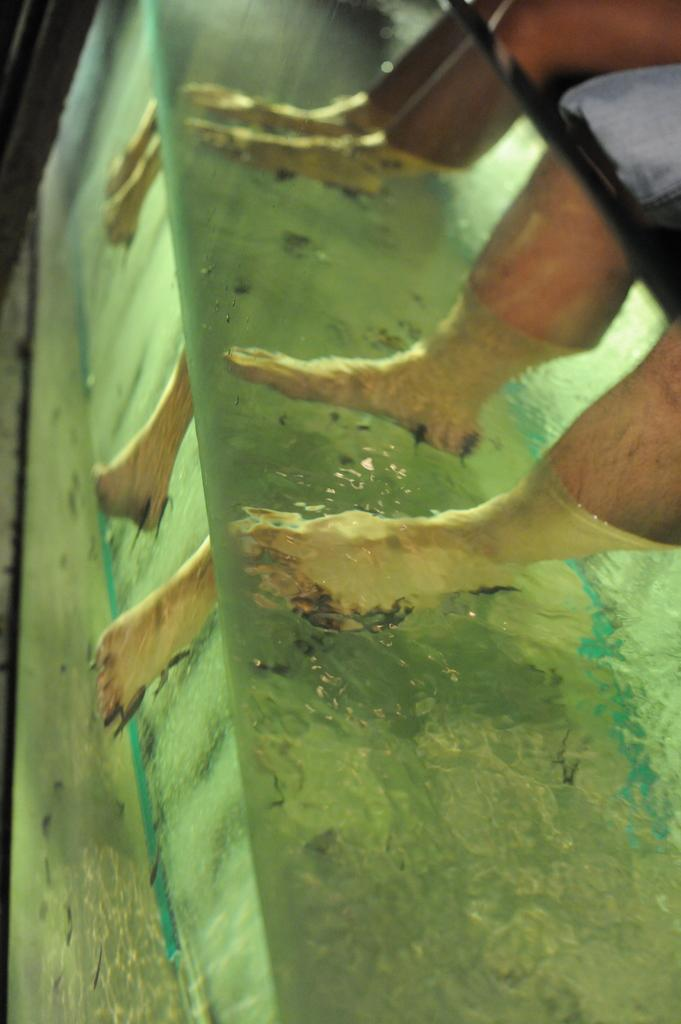How many people are present in the image based on the visible legs? There are two persons present in the image based on the visible legs. What is the primary element visible in the image? Water is visible in the image. What object can be used for self-reflection or grooming in the image? There is a mirror in the image. What type of lead can be seen in the image? There is no lead present in the image. Can you hear a whistle in the image? There is no whistle present in the image, so it cannot be heard. 